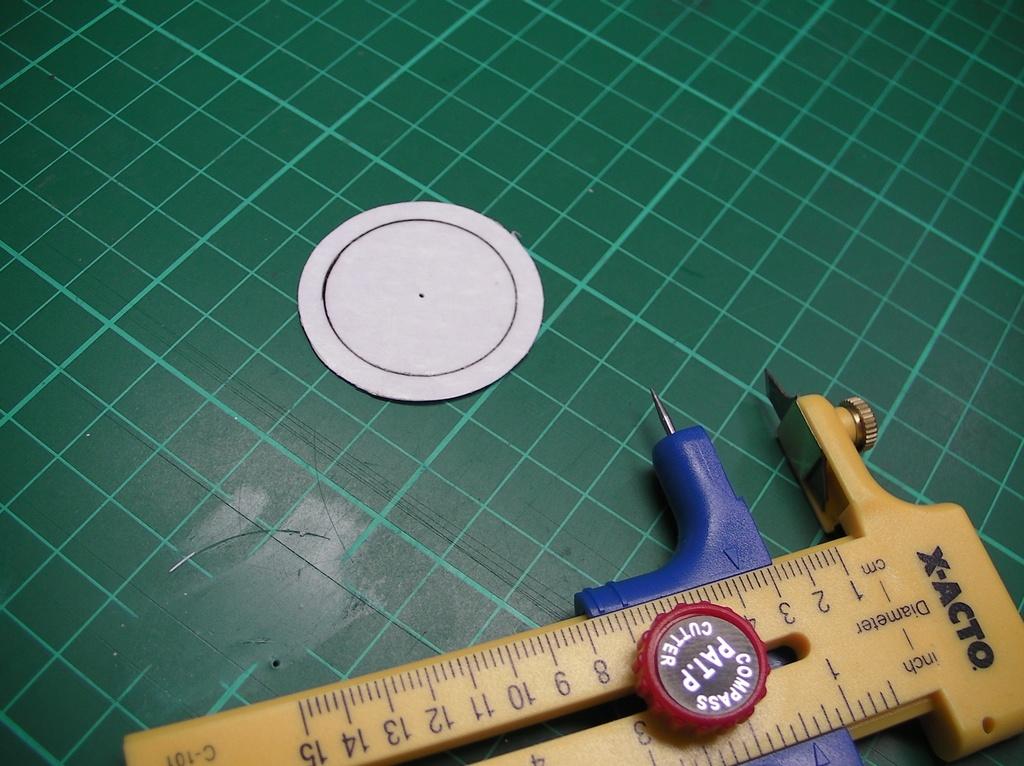What is the measurement set to?
Ensure brevity in your answer.  4. 